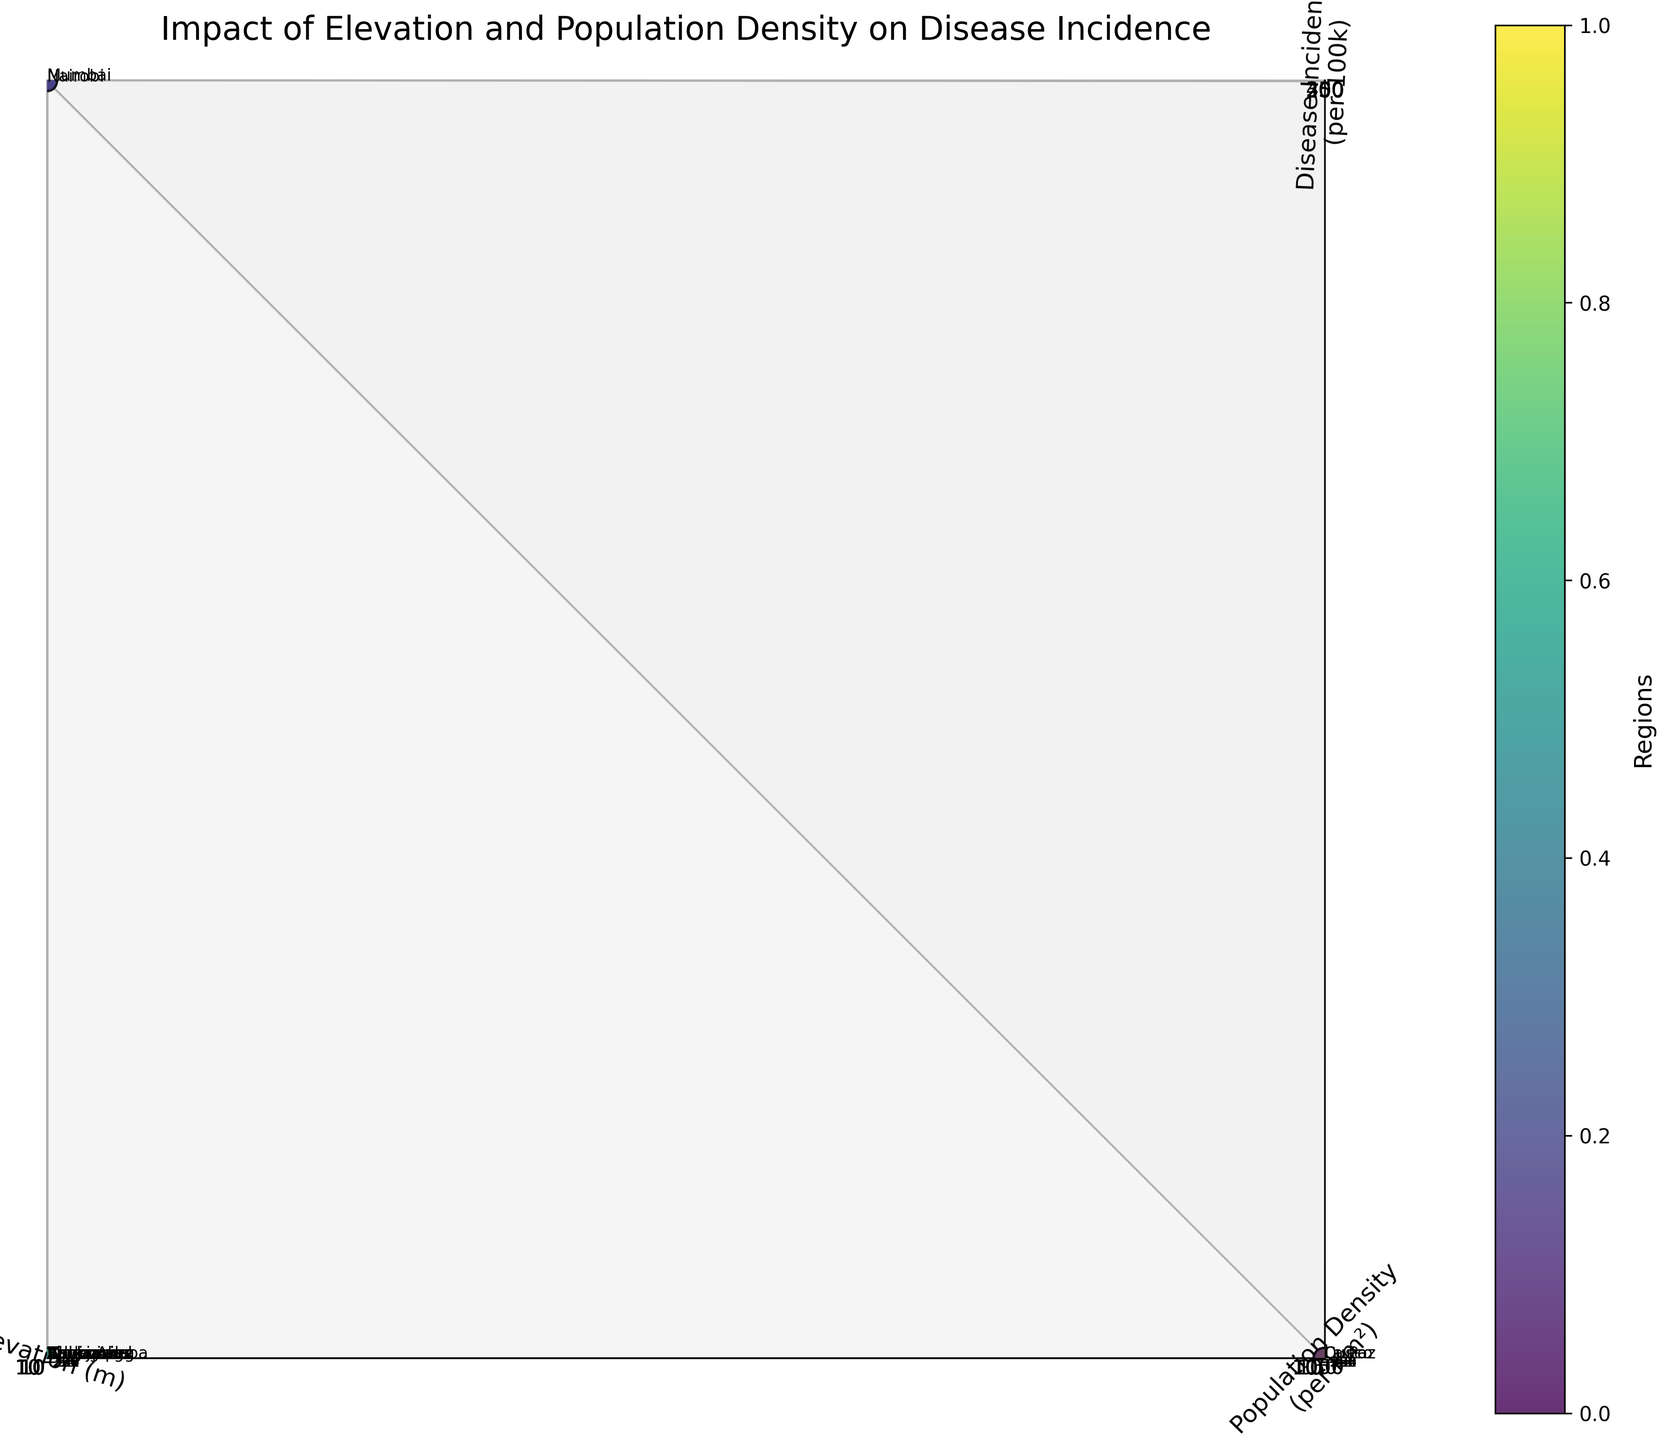What's the title of the figure? The title is located at the top of the 3D plot. It is designed to give an overarching description of the key insight being visualized. The title in this plot is "Impact of Elevation and Population Density on Disease Incidence".
Answer: Impact of Elevation and Population Density on Disease Incidence Which region has the highest disease incidence? To find the region with the highest disease incidence, look for the data point with the highest value on the z-axis (Disease Incidence per 100k). The highest z-value corresponds to Mumbai with a disease incidence of 412 per 100k.
Answer: Mumbai What are the axes labels showing? The labels for the axes can be found along the sides of the plot. The x-axis is 'Elevation (m)', the y-axis is 'Population Density (per km²)', and the z-axis is 'Disease Incidence (per 100k)'.
Answer: Elevation (m), Population Density (per km²), Disease Incidence (per 100k) Which regions are located at the highest elevation? Regions located at the highest elevation will have the highest x-axis values. The regions with the highest elevations are La Paz (3640 m) and Cusco (3399 m).
Answer: La Paz, Cusco How does population density relate to disease incidence among tropical regions? To analyze this relationship, examine the data points labeled as tropical regions (Amazonas, Nairobi, Mumbai, Singapore). Among these, Mumbai with the highest population density (21,000 per km²) has a high disease incidence (412 per 100k), indicating a potential correlation between high population density and higher disease incidence.
Answer: Higher population density correlates with higher disease incidence Which region has the lowest population density, and what is its disease incidence? Find the region with the lowest y-axis value. Amazonas has the lowest population density (2.2 per km²), and its disease incidence is 247 per 100k.
Answer: Amazonas, 247 per 100k Compare the disease incidence between regions with similar elevations but different population densities. Taking Addis Ababa and Quito as an example. Compare the z-values of Addis Ababa and Quito, which have similar elevations (2355 m and 2850 m respectively). Addis Ababa has higher population density (5165 per km²) and higher disease incidence (289 per 100k), while Quito with lower population density (4773 per km²) has a disease incidence of 137 per 100k.
Answer: Addis Ababa has higher disease incidence What can be inferred about the relationship between elevation and disease incidence? To infer the relationship, observe the general trend of z-values in relation to x-values. Higher elevations (e.g., Cusco, La Paz) do not consistently exhibit lower or higher disease incidence, indicating that elevation alone may not have a simple direct correlation with disease incidence.
Answer: No simple direct correlation Identify three regions with similar population densities but varying disease incidence. Look for regions grouped closely along the y-axis but spread out along the z-axis. Three such regions are: Phoenix (1253 per km², 85 per 100k), Oslo (1552 per km², 42 per 100k), and Nairobi (6547 per km², 328 per 100k).
Answer: Phoenix, Oslo, Nairobi 